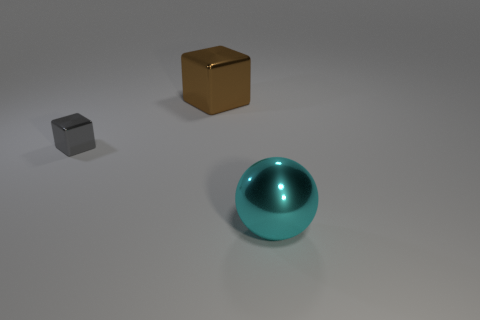Add 2 metallic spheres. How many objects exist? 5 Subtract all blocks. How many objects are left? 1 Subtract all big blue cubes. Subtract all large brown blocks. How many objects are left? 2 Add 3 balls. How many balls are left? 4 Add 1 small blue cylinders. How many small blue cylinders exist? 1 Subtract 0 red spheres. How many objects are left? 3 